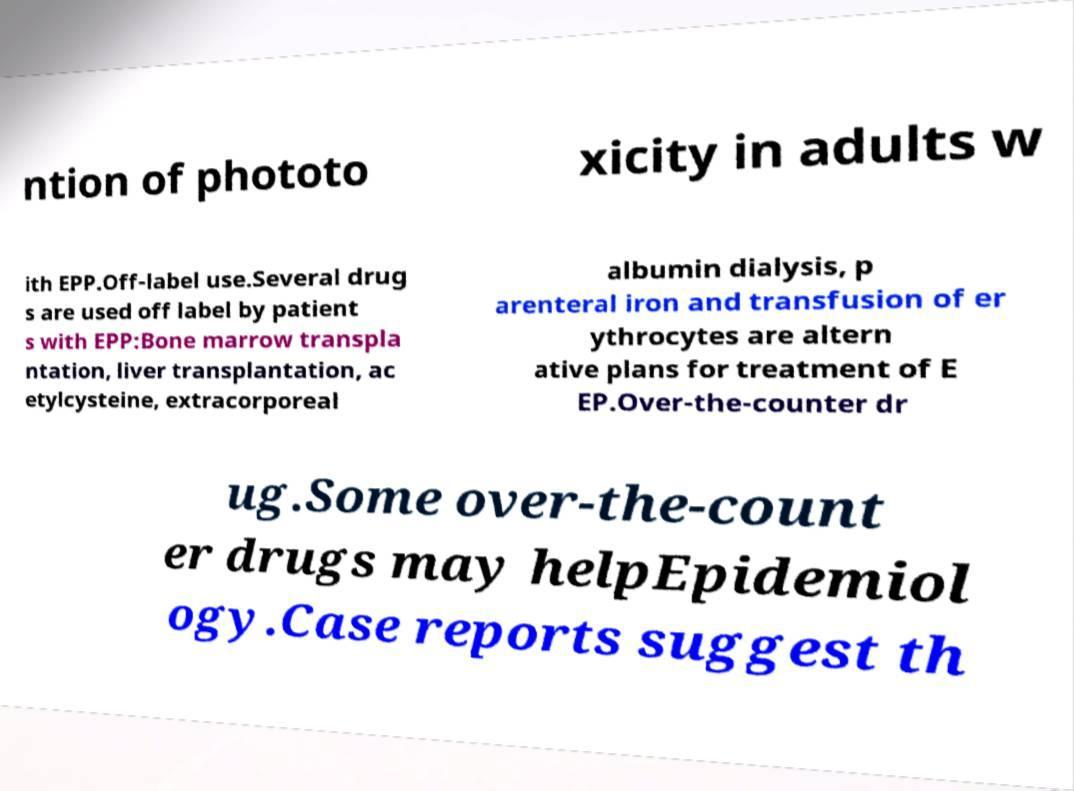Could you extract and type out the text from this image? ntion of phototo xicity in adults w ith EPP.Off-label use.Several drug s are used off label by patient s with EPP:Bone marrow transpla ntation, liver transplantation, ac etylcysteine, extracorporeal albumin dialysis, p arenteral iron and transfusion of er ythrocytes are altern ative plans for treatment of E EP.Over-the-counter dr ug.Some over-the-count er drugs may helpEpidemiol ogy.Case reports suggest th 